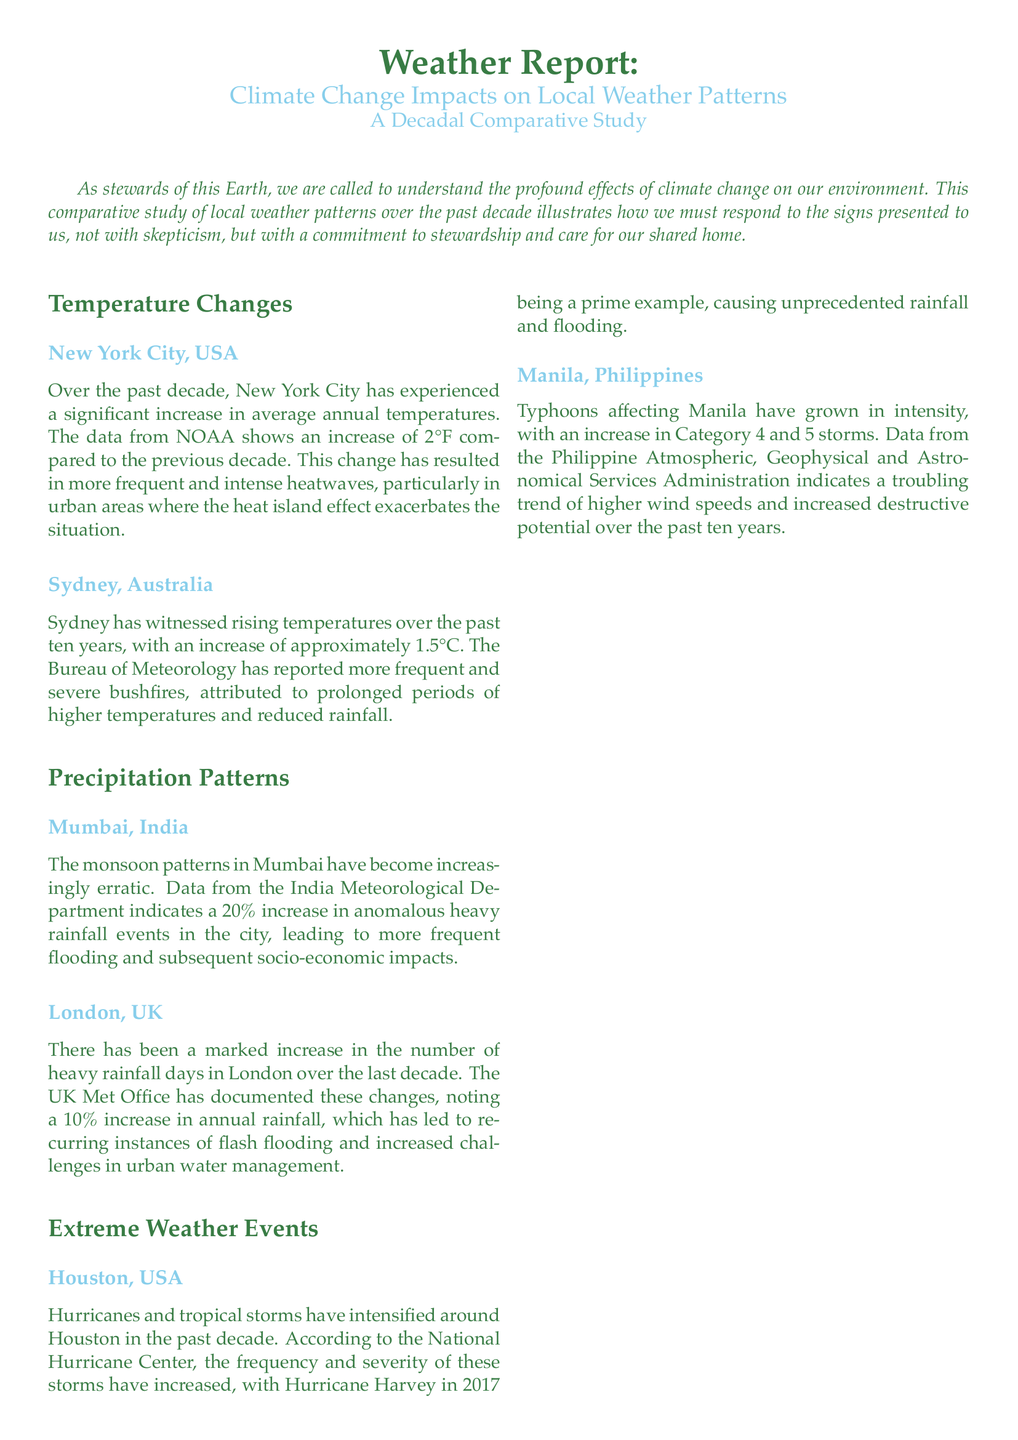What is the temperature increase in New York City? The document states that New York City has experienced a significant increase of 2°F in average annual temperatures.
Answer: 2°F What has been reported as a result of higher temperatures in Sydney? The Bureau of Meteorology has noted more frequent and severe bushfires due to prolonged periods of higher temperatures and reduced rainfall.
Answer: Severe bushfires What percentage increase in anomalous heavy rainfall events has Mumbai faced? The India Meteorological Department indicates a 20% increase in anomalous heavy rainfall events in Mumbai.
Answer: 20% What has London experienced in terms of annual rainfall over the past decade? The UK Met Office has documented a 10% increase in annual rainfall in London.
Answer: 10% What type of storms have intensified around Houston? The document specifically mentions hurricanes and tropical storms have intensified around Houston.
Answer: Hurricanes and tropical storms What has been the trend of typhoons affecting Manila? The Philippine Atmospheric, Geophysical and Astronomical Services Administration indicates that typhoons affecting Manila have grown in intensity, particularly in Category 4 and 5 storms.
Answer: Increased intensity Which hurricane exemplifies the unprecedented rainfall and flooding in Houston? The document refers to Hurricane Harvey in 2017 as a prime example of unprecedented rainfall and flooding.
Answer: Hurricane Harvey What is the main call to action presented in the conclusion? The conclusion emphasizes the need for collective action to mitigate the adverse impacts of climate change.
Answer: Collective action What color represents the title "Weather Report"? The title is colored earth green, as indicated in the document.
Answer: Earth green 